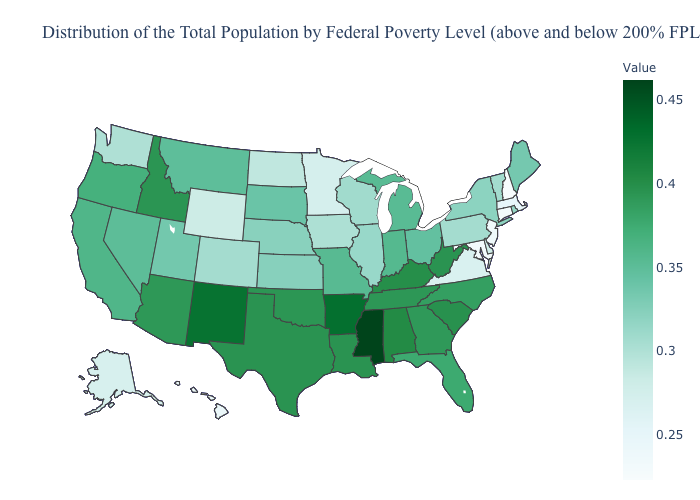Is the legend a continuous bar?
Answer briefly. Yes. Which states have the highest value in the USA?
Short answer required. Mississippi. Does Washington have a higher value than Alaska?
Quick response, please. Yes. Which states have the lowest value in the USA?
Give a very brief answer. New Hampshire. Which states have the highest value in the USA?
Quick response, please. Mississippi. Does Ohio have a lower value than Kentucky?
Keep it brief. Yes. 